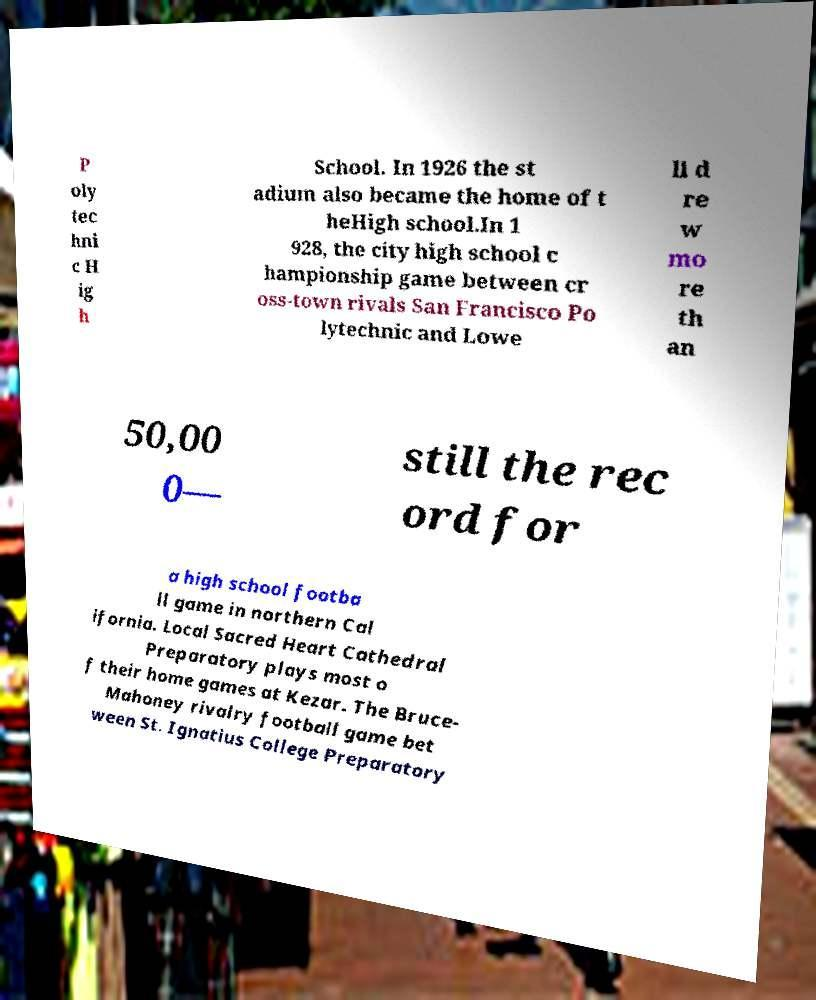For documentation purposes, I need the text within this image transcribed. Could you provide that? P oly tec hni c H ig h School. In 1926 the st adium also became the home of t heHigh school.In 1 928, the city high school c hampionship game between cr oss-town rivals San Francisco Po lytechnic and Lowe ll d re w mo re th an 50,00 0— still the rec ord for a high school footba ll game in northern Cal ifornia. Local Sacred Heart Cathedral Preparatory plays most o f their home games at Kezar. The Bruce- Mahoney rivalry football game bet ween St. Ignatius College Preparatory 